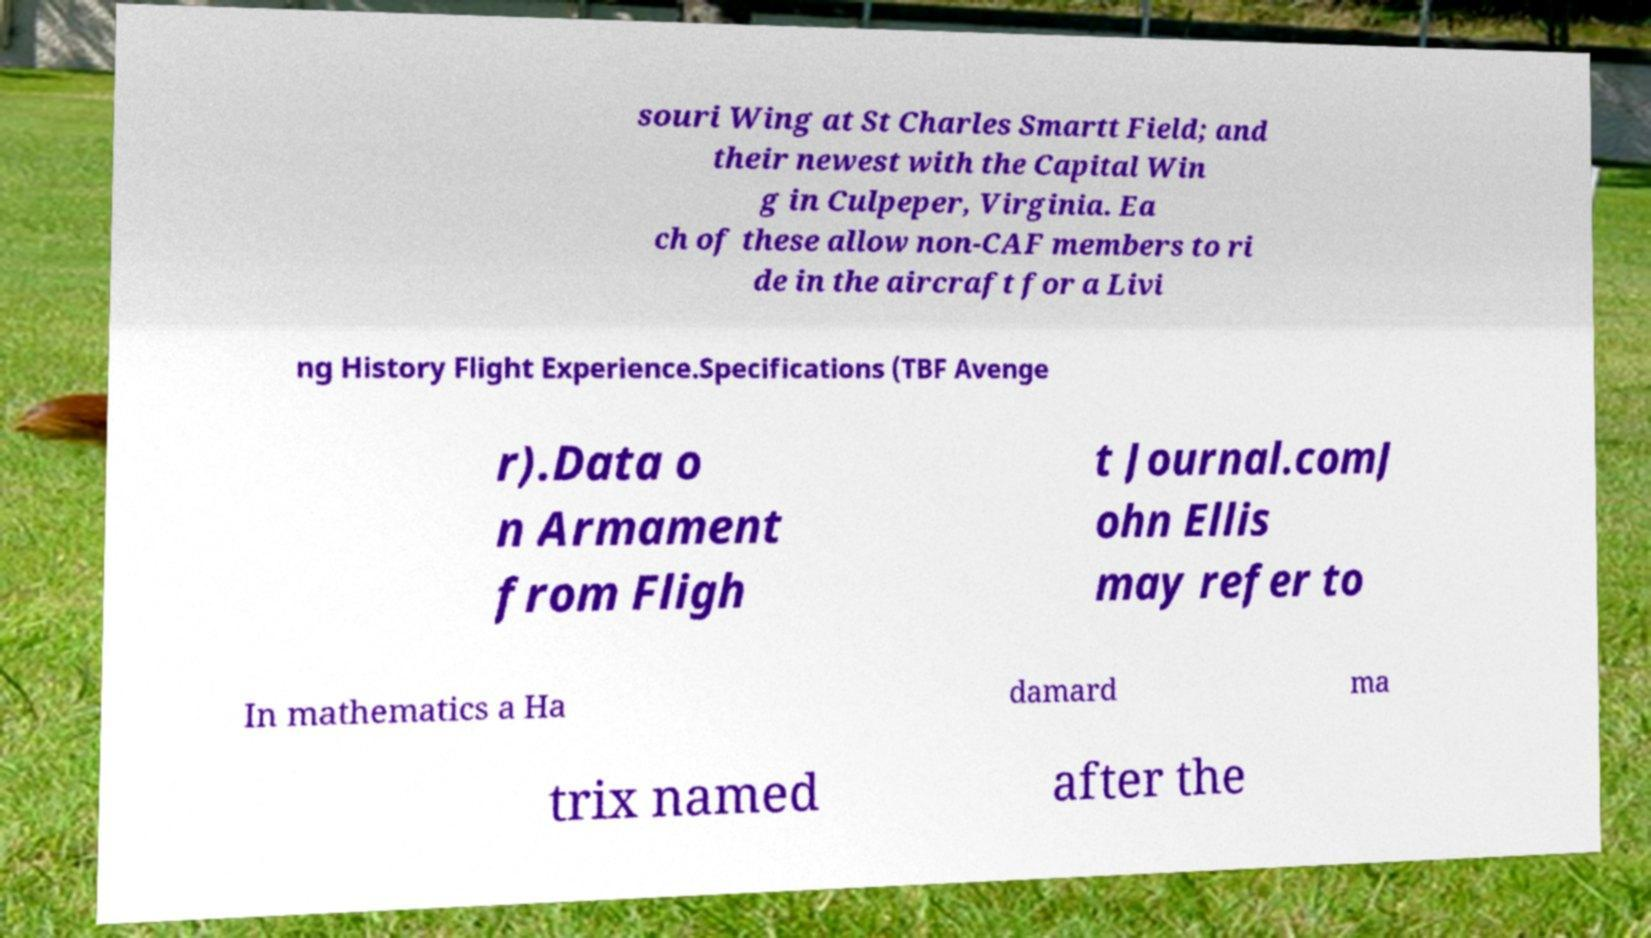For documentation purposes, I need the text within this image transcribed. Could you provide that? souri Wing at St Charles Smartt Field; and their newest with the Capital Win g in Culpeper, Virginia. Ea ch of these allow non-CAF members to ri de in the aircraft for a Livi ng History Flight Experience.Specifications (TBF Avenge r).Data o n Armament from Fligh t Journal.comJ ohn Ellis may refer to In mathematics a Ha damard ma trix named after the 